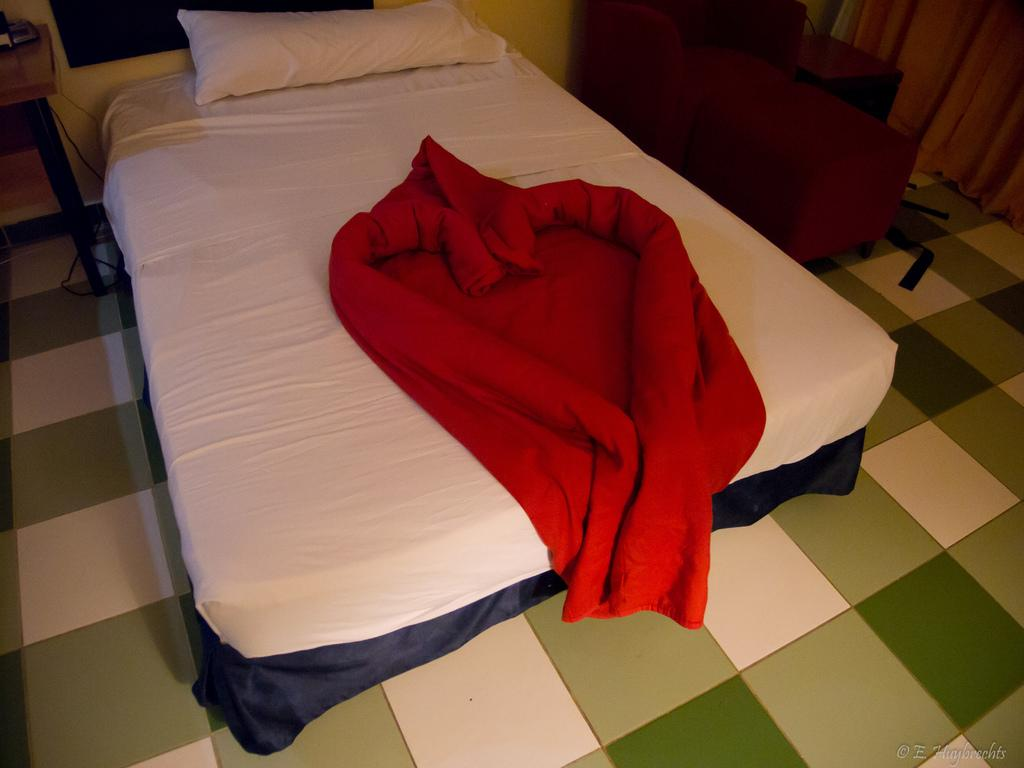What is placed on the floor in the image? There is a bed placed on the floor. What is on top of the bed? There is a pillow and a red cloth on the bed. What can be seen in the background of the image? There is a chair, curtains, a television on the wall, and a table in the background. Can you hear the sound of a drum in the image? There is no drum present in the image, so it is not possible to hear its sound. 